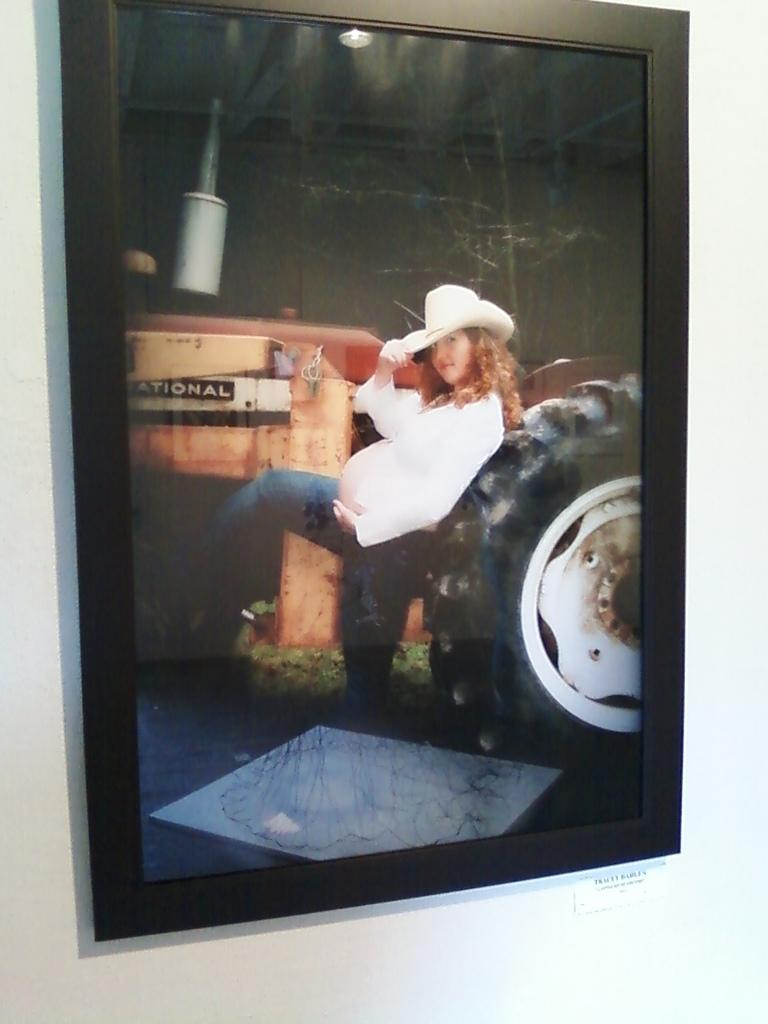What is the main subject of the image? There is a portrait in the image. What type of motion can be seen in the portrait? There is no motion present in the portrait, as it is a still image. What is the voice of the person in the portrait? The portrait is a still image and does not have a voice. 